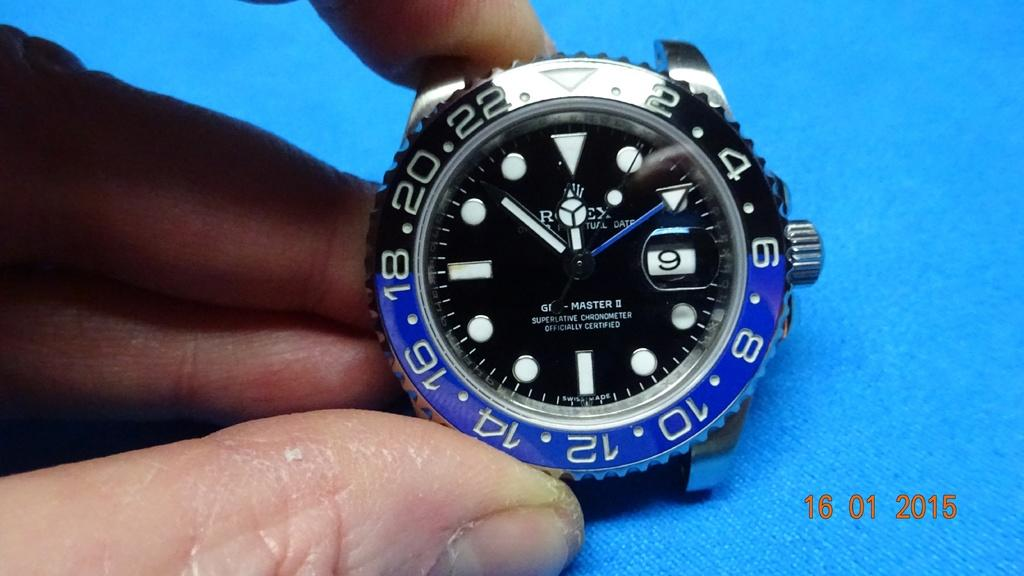<image>
Create a compact narrative representing the image presented. A Rolex watch is held up by a hand in the year 2015. 